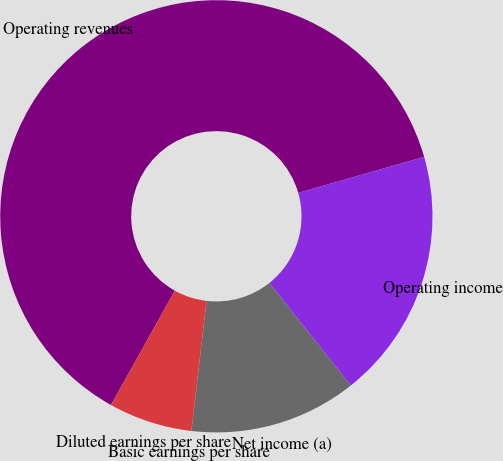<chart> <loc_0><loc_0><loc_500><loc_500><pie_chart><fcel>Operating revenues<fcel>Operating income<fcel>Net income (a)<fcel>Basic earnings per share<fcel>Diluted earnings per share<nl><fcel>62.46%<fcel>18.75%<fcel>12.51%<fcel>0.02%<fcel>6.26%<nl></chart> 